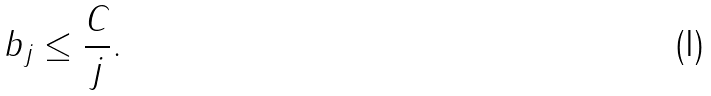<formula> <loc_0><loc_0><loc_500><loc_500>b _ { j } \leq \frac { C } { j } .</formula> 